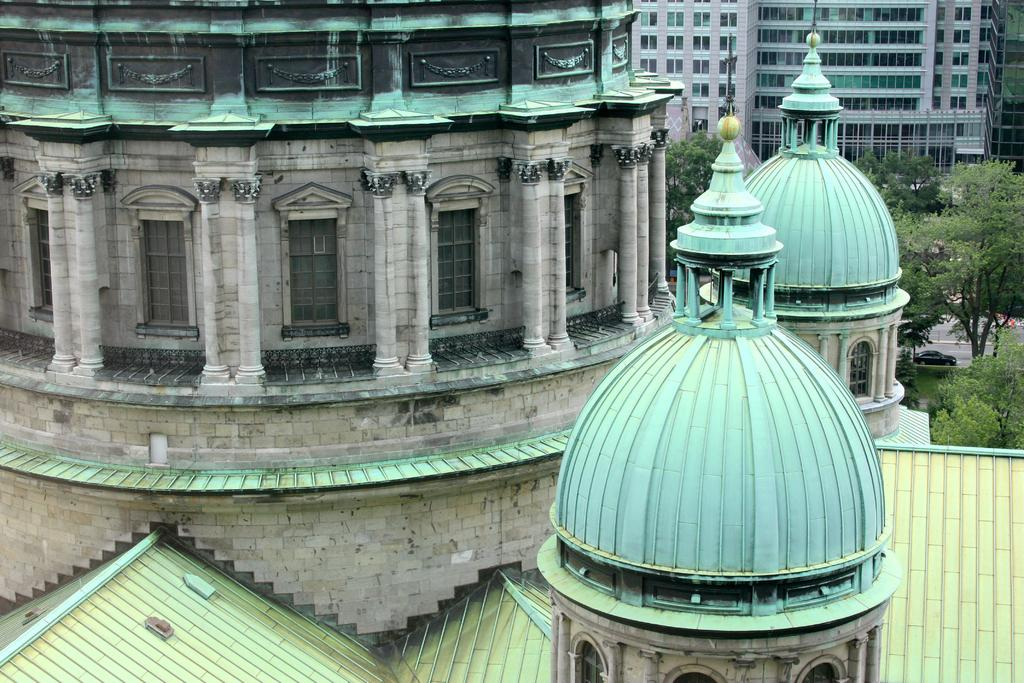What type of structures can be seen in the image? There are buildings in the image. What natural elements are present in the image? There are trees in the image. What type of transportation is visible in the image? There is a car passing on the road in the image. What type of crate is being used by the authority in the image? There is no crate or authority present in the image. 